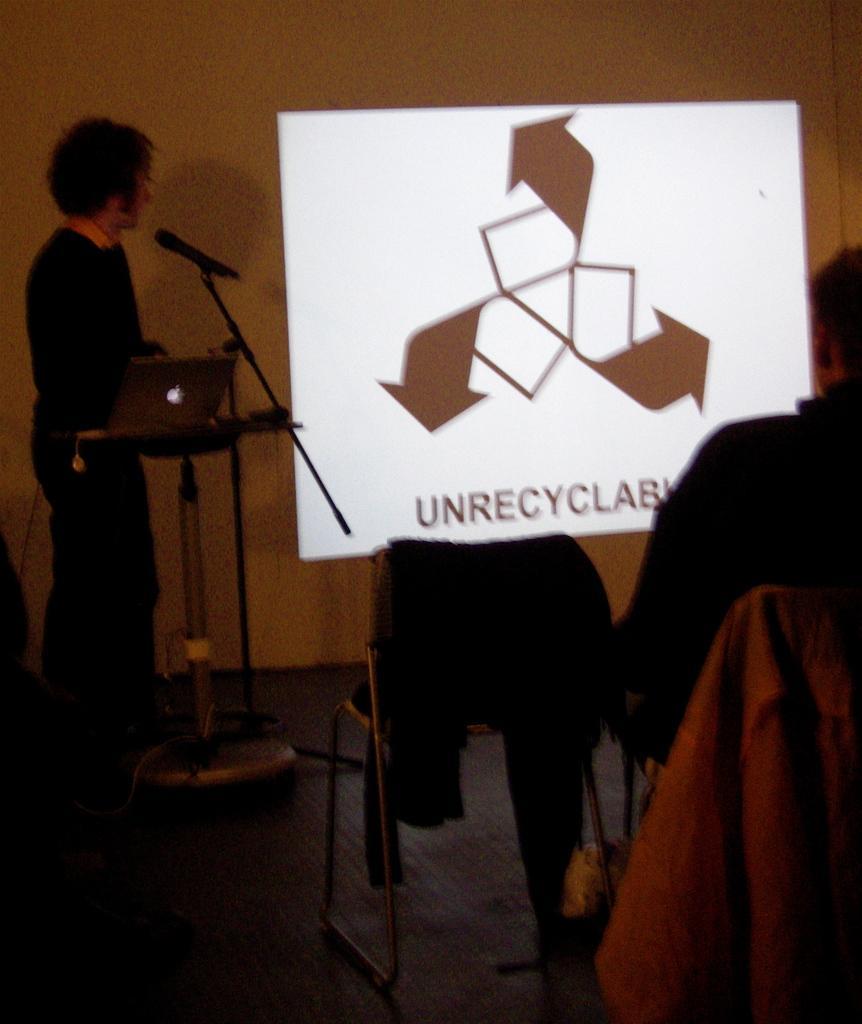Describe this image in one or two sentences. In this picture, there is a man standing at the podium. On the podium, there is a laptop. Before him, there is a mike. Towards the right, there are chairs and a person is sitting on one of them. Before him, there is a screen with some text. 